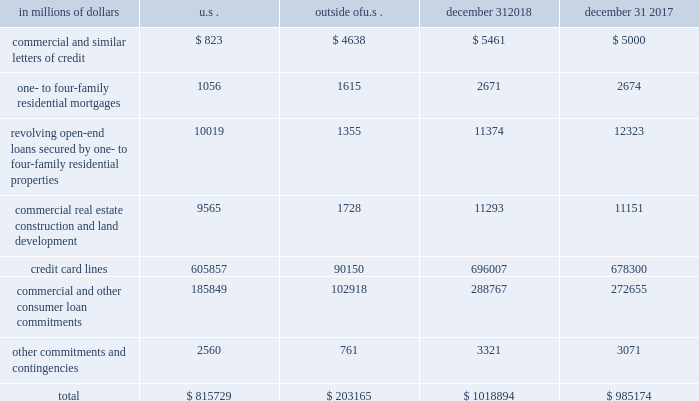Credit commitments and lines of credit the table below summarizes citigroup 2019s credit commitments : in millions of dollars u.s .
Outside of u.s .
December 31 , december 31 .
The majority of unused commitments are contingent upon customers maintaining specific credit standards .
Commercial commitments generally have floating interest rates and fixed expiration dates and may require payment of fees .
Such fees ( net of certain direct costs ) are deferred and , upon exercise of the commitment , amortized over the life of the loan or , if exercise is deemed remote , amortized over the commitment period .
Commercial and similar letters of credit a commercial letter of credit is an instrument by which citigroup substitutes its credit for that of a customer to enable the customer to finance the purchase of goods or to incur other commitments .
Citigroup issues a letter on behalf of its client to a supplier and agrees to pay the supplier upon presentation of documentary evidence that the supplier has performed in accordance with the terms of the letter of credit .
When a letter of credit is drawn , the customer is then required to reimburse citigroup .
One- to four-family residential mortgages a one- to four-family residential mortgage commitment is a written confirmation from citigroup to a seller of a property that the bank will advance the specified sums enabling the buyer to complete the purchase .
Revolving open-end loans secured by one- to four-family residential properties revolving open-end loans secured by one- to four-family residential properties are essentially home equity lines of credit .
A home equity line of credit is a loan secured by a primary residence or second home to the extent of the excess of fair market value over the debt outstanding for the first mortgage .
Commercial real estate , construction and land development commercial real estate , construction and land development include unused portions of commitments to extend credit for the purpose of financing commercial and multifamily residential properties as well as land development projects .
Both secured-by-real-estate and unsecured commitments are included in this line , as well as undistributed loan proceeds , where there is an obligation to advance for construction progress payments .
However , this line only includes those extensions of credit that , once funded , will be classified as total loans , net on the consolidated balance sheet .
Credit card lines citigroup provides credit to customers by issuing credit cards .
The credit card lines are cancelable by providing notice to the cardholder or without such notice as permitted by local law .
Commercial and other consumer loan commitments commercial and other consumer loan commitments include overdraft and liquidity facilities as well as commercial commitments to make or purchase loans , purchase third-party receivables , provide note issuance or revolving underwriting facilities and invest in the form of equity .
Other commitments and contingencies other commitments and contingencies include committed or unsettled regular-way reverse repurchase agreements and all other transactions related to commitments and contingencies not reported on the lines above .
Unsettled reverse repurchase and securities lending agreements and unsettled repurchase and securities borrowing agreements in addition , in the normal course of business , citigroup enters into reverse repurchase and securities borrowing agreements , as well as repurchase and securities lending agreements , which settle at a future date .
At december 31 , 2018 , and 2017 , citigroup had $ 36.1 billion and $ 35.0 billion unsettled reverse repurchase and securities borrowing agreements , respectively , and $ 30.7 billion and $ 19.1 billion unsettled repurchase and securities lending agreements , respectively .
For a further discussion of securities purchased under agreements to resell and securities borrowed , and securities sold under agreements to repurchase and securities loaned , including the company 2019s policy for offsetting repurchase and reverse repurchase agreements , see note 11 to the consolidated financial statements. .
What was the credit commitments and lines of credit total from 2017 to 2018? 
Rationale: the credit commitments and lines of credit total increased by 3.4% from 2017 to 2018
Computations: ((1018894 - 985174) / 985174)
Answer: 0.03423. Credit commitments and lines of credit the table below summarizes citigroup 2019s credit commitments : in millions of dollars u.s .
Outside of u.s .
December 31 , december 31 .
The majority of unused commitments are contingent upon customers maintaining specific credit standards .
Commercial commitments generally have floating interest rates and fixed expiration dates and may require payment of fees .
Such fees ( net of certain direct costs ) are deferred and , upon exercise of the commitment , amortized over the life of the loan or , if exercise is deemed remote , amortized over the commitment period .
Commercial and similar letters of credit a commercial letter of credit is an instrument by which citigroup substitutes its credit for that of a customer to enable the customer to finance the purchase of goods or to incur other commitments .
Citigroup issues a letter on behalf of its client to a supplier and agrees to pay the supplier upon presentation of documentary evidence that the supplier has performed in accordance with the terms of the letter of credit .
When a letter of credit is drawn , the customer is then required to reimburse citigroup .
One- to four-family residential mortgages a one- to four-family residential mortgage commitment is a written confirmation from citigroup to a seller of a property that the bank will advance the specified sums enabling the buyer to complete the purchase .
Revolving open-end loans secured by one- to four-family residential properties revolving open-end loans secured by one- to four-family residential properties are essentially home equity lines of credit .
A home equity line of credit is a loan secured by a primary residence or second home to the extent of the excess of fair market value over the debt outstanding for the first mortgage .
Commercial real estate , construction and land development commercial real estate , construction and land development include unused portions of commitments to extend credit for the purpose of financing commercial and multifamily residential properties as well as land development projects .
Both secured-by-real-estate and unsecured commitments are included in this line , as well as undistributed loan proceeds , where there is an obligation to advance for construction progress payments .
However , this line only includes those extensions of credit that , once funded , will be classified as total loans , net on the consolidated balance sheet .
Credit card lines citigroup provides credit to customers by issuing credit cards .
The credit card lines are cancelable by providing notice to the cardholder or without such notice as permitted by local law .
Commercial and other consumer loan commitments commercial and other consumer loan commitments include overdraft and liquidity facilities as well as commercial commitments to make or purchase loans , purchase third-party receivables , provide note issuance or revolving underwriting facilities and invest in the form of equity .
Other commitments and contingencies other commitments and contingencies include committed or unsettled regular-way reverse repurchase agreements and all other transactions related to commitments and contingencies not reported on the lines above .
Unsettled reverse repurchase and securities lending agreements and unsettled repurchase and securities borrowing agreements in addition , in the normal course of business , citigroup enters into reverse repurchase and securities borrowing agreements , as well as repurchase and securities lending agreements , which settle at a future date .
At december 31 , 2018 , and 2017 , citigroup had $ 36.1 billion and $ 35.0 billion unsettled reverse repurchase and securities borrowing agreements , respectively , and $ 30.7 billion and $ 19.1 billion unsettled repurchase and securities lending agreements , respectively .
For a further discussion of securities purchased under agreements to resell and securities borrowed , and securities sold under agreements to repurchase and securities loaned , including the company 2019s policy for offsetting repurchase and reverse repurchase agreements , see note 11 to the consolidated financial statements. .
What percentage of total credit commitments as of december 31 , 2018 are credit card lines? 
Computations: (696007 / 1018894)
Answer: 0.6831. Credit commitments and lines of credit the table below summarizes citigroup 2019s credit commitments : in millions of dollars u.s .
Outside of u.s .
December 31 , december 31 .
The majority of unused commitments are contingent upon customers maintaining specific credit standards .
Commercial commitments generally have floating interest rates and fixed expiration dates and may require payment of fees .
Such fees ( net of certain direct costs ) are deferred and , upon exercise of the commitment , amortized over the life of the loan or , if exercise is deemed remote , amortized over the commitment period .
Commercial and similar letters of credit a commercial letter of credit is an instrument by which citigroup substitutes its credit for that of a customer to enable the customer to finance the purchase of goods or to incur other commitments .
Citigroup issues a letter on behalf of its client to a supplier and agrees to pay the supplier upon presentation of documentary evidence that the supplier has performed in accordance with the terms of the letter of credit .
When a letter of credit is drawn , the customer is then required to reimburse citigroup .
One- to four-family residential mortgages a one- to four-family residential mortgage commitment is a written confirmation from citigroup to a seller of a property that the bank will advance the specified sums enabling the buyer to complete the purchase .
Revolving open-end loans secured by one- to four-family residential properties revolving open-end loans secured by one- to four-family residential properties are essentially home equity lines of credit .
A home equity line of credit is a loan secured by a primary residence or second home to the extent of the excess of fair market value over the debt outstanding for the first mortgage .
Commercial real estate , construction and land development commercial real estate , construction and land development include unused portions of commitments to extend credit for the purpose of financing commercial and multifamily residential properties as well as land development projects .
Both secured-by-real-estate and unsecured commitments are included in this line , as well as undistributed loan proceeds , where there is an obligation to advance for construction progress payments .
However , this line only includes those extensions of credit that , once funded , will be classified as total loans , net on the consolidated balance sheet .
Credit card lines citigroup provides credit to customers by issuing credit cards .
The credit card lines are cancelable by providing notice to the cardholder or without such notice as permitted by local law .
Commercial and other consumer loan commitments commercial and other consumer loan commitments include overdraft and liquidity facilities as well as commercial commitments to make or purchase loans , purchase third-party receivables , provide note issuance or revolving underwriting facilities and invest in the form of equity .
Other commitments and contingencies other commitments and contingencies include committed or unsettled regular-way reverse repurchase agreements and all other transactions related to commitments and contingencies not reported on the lines above .
Unsettled reverse repurchase and securities lending agreements and unsettled repurchase and securities borrowing agreements in addition , in the normal course of business , citigroup enters into reverse repurchase and securities borrowing agreements , as well as repurchase and securities lending agreements , which settle at a future date .
At december 31 , 2018 , and 2017 , citigroup had $ 36.1 billion and $ 35.0 billion unsettled reverse repurchase and securities borrowing agreements , respectively , and $ 30.7 billion and $ 19.1 billion unsettled repurchase and securities lending agreements , respectively .
For a further discussion of securities purchased under agreements to resell and securities borrowed , and securities sold under agreements to repurchase and securities loaned , including the company 2019s policy for offsetting repurchase and reverse repurchase agreements , see note 11 to the consolidated financial statements. .
In 2018 what was the ratio of the unsettled reverse repurchase to the unsettled repurchase? 
Rationale: in 2018 there was $ 1.18 unsettled reverse repurchase to the unsettled repurchase agreements
Computations: (36.1 / 30.7)
Answer: 1.1759. 